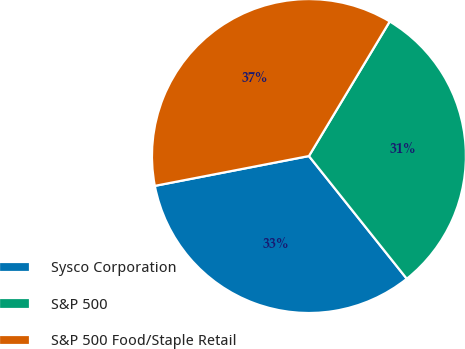<chart> <loc_0><loc_0><loc_500><loc_500><pie_chart><fcel>Sysco Corporation<fcel>S&P 500<fcel>S&P 500 Food/Staple Retail<nl><fcel>32.67%<fcel>30.68%<fcel>36.65%<nl></chart> 